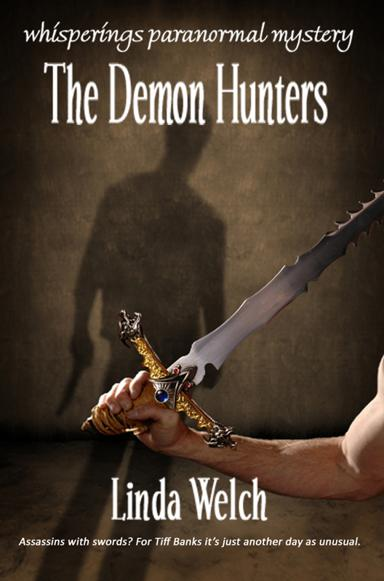How does the design of the sword on the cover reflect the themes of the book? The sword's intricate design, featuring menacing edges and an elaborate hilt, encapsulates a sense of historical depth and supernatural undertones, which are central to themes of battling otherworldly entities in 'The Demon Hunters.' 